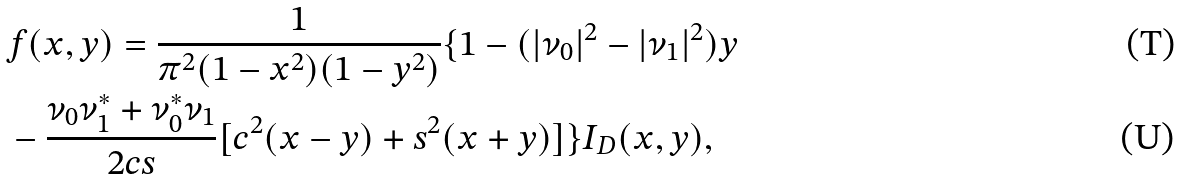<formula> <loc_0><loc_0><loc_500><loc_500>& f ( x , y ) = \frac { 1 } { \pi ^ { 2 } ( 1 - x ^ { 2 } ) ( 1 - y ^ { 2 } ) } \{ 1 - ( | \nu _ { 0 } | ^ { 2 } - | \nu _ { 1 } | ^ { 2 } ) y \\ & - \frac { \nu _ { 0 } \nu _ { 1 } ^ { * } + \nu _ { 0 } ^ { * } \nu _ { 1 } } { 2 c s } [ c ^ { 2 } ( x - y ) + s ^ { 2 } ( x + y ) ] \} I _ { D } ( x , y ) ,</formula> 